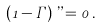Convert formula to latex. <formula><loc_0><loc_0><loc_500><loc_500>\left ( 1 - \Gamma \right ) \varepsilon = 0 \, .</formula> 